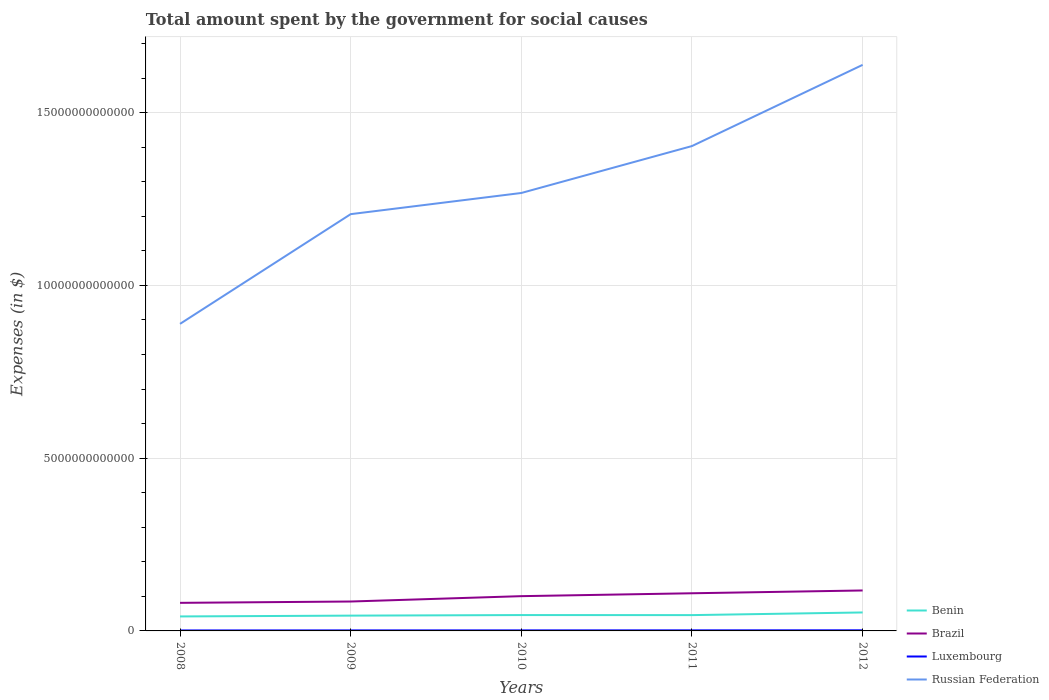Is the number of lines equal to the number of legend labels?
Give a very brief answer. Yes. Across all years, what is the maximum amount spent for social causes by the government in Benin?
Give a very brief answer. 4.19e+11. In which year was the amount spent for social causes by the government in Russian Federation maximum?
Offer a very short reply. 2008. What is the total amount spent for social causes by the government in Brazil in the graph?
Your answer should be compact. -1.55e+11. What is the difference between the highest and the second highest amount spent for social causes by the government in Brazil?
Your response must be concise. 3.58e+11. How many lines are there?
Make the answer very short. 4. What is the difference between two consecutive major ticks on the Y-axis?
Your answer should be very brief. 5.00e+12. Are the values on the major ticks of Y-axis written in scientific E-notation?
Your answer should be compact. No. What is the title of the graph?
Offer a very short reply. Total amount spent by the government for social causes. Does "Bahamas" appear as one of the legend labels in the graph?
Your answer should be very brief. No. What is the label or title of the Y-axis?
Provide a succinct answer. Expenses (in $). What is the Expenses (in $) of Benin in 2008?
Your response must be concise. 4.19e+11. What is the Expenses (in $) in Brazil in 2008?
Offer a very short reply. 8.13e+11. What is the Expenses (in $) of Luxembourg in 2008?
Keep it short and to the point. 1.34e+1. What is the Expenses (in $) in Russian Federation in 2008?
Provide a short and direct response. 8.89e+12. What is the Expenses (in $) of Benin in 2009?
Offer a very short reply. 4.43e+11. What is the Expenses (in $) in Brazil in 2009?
Your answer should be compact. 8.51e+11. What is the Expenses (in $) of Luxembourg in 2009?
Ensure brevity in your answer.  1.47e+1. What is the Expenses (in $) in Russian Federation in 2009?
Keep it short and to the point. 1.21e+13. What is the Expenses (in $) of Benin in 2010?
Offer a very short reply. 4.59e+11. What is the Expenses (in $) in Brazil in 2010?
Give a very brief answer. 1.01e+12. What is the Expenses (in $) in Luxembourg in 2010?
Your answer should be very brief. 1.56e+1. What is the Expenses (in $) of Russian Federation in 2010?
Offer a terse response. 1.27e+13. What is the Expenses (in $) in Benin in 2011?
Give a very brief answer. 4.58e+11. What is the Expenses (in $) in Brazil in 2011?
Provide a succinct answer. 1.09e+12. What is the Expenses (in $) of Luxembourg in 2011?
Your answer should be very brief. 1.63e+1. What is the Expenses (in $) of Russian Federation in 2011?
Keep it short and to the point. 1.40e+13. What is the Expenses (in $) in Benin in 2012?
Your response must be concise. 5.35e+11. What is the Expenses (in $) of Brazil in 2012?
Ensure brevity in your answer.  1.17e+12. What is the Expenses (in $) of Luxembourg in 2012?
Offer a very short reply. 1.76e+1. What is the Expenses (in $) of Russian Federation in 2012?
Offer a very short reply. 1.64e+13. Across all years, what is the maximum Expenses (in $) of Benin?
Make the answer very short. 5.35e+11. Across all years, what is the maximum Expenses (in $) of Brazil?
Your answer should be compact. 1.17e+12. Across all years, what is the maximum Expenses (in $) in Luxembourg?
Offer a very short reply. 1.76e+1. Across all years, what is the maximum Expenses (in $) of Russian Federation?
Keep it short and to the point. 1.64e+13. Across all years, what is the minimum Expenses (in $) in Benin?
Your answer should be compact. 4.19e+11. Across all years, what is the minimum Expenses (in $) in Brazil?
Offer a terse response. 8.13e+11. Across all years, what is the minimum Expenses (in $) in Luxembourg?
Your response must be concise. 1.34e+1. Across all years, what is the minimum Expenses (in $) of Russian Federation?
Your answer should be compact. 8.89e+12. What is the total Expenses (in $) of Benin in the graph?
Make the answer very short. 2.31e+12. What is the total Expenses (in $) of Brazil in the graph?
Provide a short and direct response. 4.93e+12. What is the total Expenses (in $) in Luxembourg in the graph?
Keep it short and to the point. 7.76e+1. What is the total Expenses (in $) in Russian Federation in the graph?
Keep it short and to the point. 6.40e+13. What is the difference between the Expenses (in $) in Benin in 2008 and that in 2009?
Keep it short and to the point. -2.35e+1. What is the difference between the Expenses (in $) in Brazil in 2008 and that in 2009?
Your answer should be very brief. -3.85e+1. What is the difference between the Expenses (in $) of Luxembourg in 2008 and that in 2009?
Your answer should be very brief. -1.27e+09. What is the difference between the Expenses (in $) of Russian Federation in 2008 and that in 2009?
Ensure brevity in your answer.  -3.18e+12. What is the difference between the Expenses (in $) in Benin in 2008 and that in 2010?
Offer a terse response. -3.99e+1. What is the difference between the Expenses (in $) in Brazil in 2008 and that in 2010?
Your answer should be compact. -1.93e+11. What is the difference between the Expenses (in $) of Luxembourg in 2008 and that in 2010?
Make the answer very short. -2.11e+09. What is the difference between the Expenses (in $) of Russian Federation in 2008 and that in 2010?
Your answer should be very brief. -3.79e+12. What is the difference between the Expenses (in $) of Benin in 2008 and that in 2011?
Your response must be concise. -3.85e+1. What is the difference between the Expenses (in $) of Brazil in 2008 and that in 2011?
Offer a very short reply. -2.77e+11. What is the difference between the Expenses (in $) of Luxembourg in 2008 and that in 2011?
Give a very brief answer. -2.88e+09. What is the difference between the Expenses (in $) in Russian Federation in 2008 and that in 2011?
Offer a very short reply. -5.15e+12. What is the difference between the Expenses (in $) in Benin in 2008 and that in 2012?
Your answer should be compact. -1.16e+11. What is the difference between the Expenses (in $) in Brazil in 2008 and that in 2012?
Make the answer very short. -3.58e+11. What is the difference between the Expenses (in $) in Luxembourg in 2008 and that in 2012?
Provide a succinct answer. -4.14e+09. What is the difference between the Expenses (in $) of Russian Federation in 2008 and that in 2012?
Provide a short and direct response. -7.50e+12. What is the difference between the Expenses (in $) of Benin in 2009 and that in 2010?
Ensure brevity in your answer.  -1.64e+1. What is the difference between the Expenses (in $) in Brazil in 2009 and that in 2010?
Offer a terse response. -1.55e+11. What is the difference between the Expenses (in $) in Luxembourg in 2009 and that in 2010?
Provide a short and direct response. -8.37e+08. What is the difference between the Expenses (in $) of Russian Federation in 2009 and that in 2010?
Provide a succinct answer. -6.13e+11. What is the difference between the Expenses (in $) of Benin in 2009 and that in 2011?
Offer a very short reply. -1.50e+1. What is the difference between the Expenses (in $) of Brazil in 2009 and that in 2011?
Make the answer very short. -2.39e+11. What is the difference between the Expenses (in $) of Luxembourg in 2009 and that in 2011?
Give a very brief answer. -1.61e+09. What is the difference between the Expenses (in $) in Russian Federation in 2009 and that in 2011?
Ensure brevity in your answer.  -1.97e+12. What is the difference between the Expenses (in $) of Benin in 2009 and that in 2012?
Ensure brevity in your answer.  -9.20e+1. What is the difference between the Expenses (in $) in Brazil in 2009 and that in 2012?
Your answer should be very brief. -3.20e+11. What is the difference between the Expenses (in $) of Luxembourg in 2009 and that in 2012?
Offer a terse response. -2.87e+09. What is the difference between the Expenses (in $) of Russian Federation in 2009 and that in 2012?
Your response must be concise. -4.32e+12. What is the difference between the Expenses (in $) in Benin in 2010 and that in 2011?
Provide a short and direct response. 1.35e+09. What is the difference between the Expenses (in $) of Brazil in 2010 and that in 2011?
Provide a succinct answer. -8.37e+1. What is the difference between the Expenses (in $) in Luxembourg in 2010 and that in 2011?
Offer a very short reply. -7.72e+08. What is the difference between the Expenses (in $) in Russian Federation in 2010 and that in 2011?
Give a very brief answer. -1.36e+12. What is the difference between the Expenses (in $) in Benin in 2010 and that in 2012?
Ensure brevity in your answer.  -7.57e+1. What is the difference between the Expenses (in $) in Brazil in 2010 and that in 2012?
Your response must be concise. -1.65e+11. What is the difference between the Expenses (in $) in Luxembourg in 2010 and that in 2012?
Offer a terse response. -2.03e+09. What is the difference between the Expenses (in $) in Russian Federation in 2010 and that in 2012?
Provide a short and direct response. -3.71e+12. What is the difference between the Expenses (in $) in Benin in 2011 and that in 2012?
Ensure brevity in your answer.  -7.70e+1. What is the difference between the Expenses (in $) of Brazil in 2011 and that in 2012?
Make the answer very short. -8.09e+1. What is the difference between the Expenses (in $) in Luxembourg in 2011 and that in 2012?
Provide a succinct answer. -1.26e+09. What is the difference between the Expenses (in $) in Russian Federation in 2011 and that in 2012?
Your response must be concise. -2.35e+12. What is the difference between the Expenses (in $) in Benin in 2008 and the Expenses (in $) in Brazil in 2009?
Your answer should be compact. -4.32e+11. What is the difference between the Expenses (in $) in Benin in 2008 and the Expenses (in $) in Luxembourg in 2009?
Ensure brevity in your answer.  4.04e+11. What is the difference between the Expenses (in $) of Benin in 2008 and the Expenses (in $) of Russian Federation in 2009?
Keep it short and to the point. -1.16e+13. What is the difference between the Expenses (in $) of Brazil in 2008 and the Expenses (in $) of Luxembourg in 2009?
Offer a very short reply. 7.98e+11. What is the difference between the Expenses (in $) in Brazil in 2008 and the Expenses (in $) in Russian Federation in 2009?
Offer a terse response. -1.13e+13. What is the difference between the Expenses (in $) in Luxembourg in 2008 and the Expenses (in $) in Russian Federation in 2009?
Offer a terse response. -1.20e+13. What is the difference between the Expenses (in $) of Benin in 2008 and the Expenses (in $) of Brazil in 2010?
Provide a succinct answer. -5.87e+11. What is the difference between the Expenses (in $) in Benin in 2008 and the Expenses (in $) in Luxembourg in 2010?
Offer a very short reply. 4.04e+11. What is the difference between the Expenses (in $) in Benin in 2008 and the Expenses (in $) in Russian Federation in 2010?
Your answer should be very brief. -1.23e+13. What is the difference between the Expenses (in $) of Brazil in 2008 and the Expenses (in $) of Luxembourg in 2010?
Provide a succinct answer. 7.97e+11. What is the difference between the Expenses (in $) in Brazil in 2008 and the Expenses (in $) in Russian Federation in 2010?
Make the answer very short. -1.19e+13. What is the difference between the Expenses (in $) of Luxembourg in 2008 and the Expenses (in $) of Russian Federation in 2010?
Keep it short and to the point. -1.27e+13. What is the difference between the Expenses (in $) in Benin in 2008 and the Expenses (in $) in Brazil in 2011?
Provide a short and direct response. -6.71e+11. What is the difference between the Expenses (in $) of Benin in 2008 and the Expenses (in $) of Luxembourg in 2011?
Provide a short and direct response. 4.03e+11. What is the difference between the Expenses (in $) of Benin in 2008 and the Expenses (in $) of Russian Federation in 2011?
Make the answer very short. -1.36e+13. What is the difference between the Expenses (in $) of Brazil in 2008 and the Expenses (in $) of Luxembourg in 2011?
Ensure brevity in your answer.  7.96e+11. What is the difference between the Expenses (in $) in Brazil in 2008 and the Expenses (in $) in Russian Federation in 2011?
Your answer should be compact. -1.32e+13. What is the difference between the Expenses (in $) in Luxembourg in 2008 and the Expenses (in $) in Russian Federation in 2011?
Offer a terse response. -1.40e+13. What is the difference between the Expenses (in $) in Benin in 2008 and the Expenses (in $) in Brazil in 2012?
Offer a very short reply. -7.52e+11. What is the difference between the Expenses (in $) of Benin in 2008 and the Expenses (in $) of Luxembourg in 2012?
Offer a terse response. 4.02e+11. What is the difference between the Expenses (in $) of Benin in 2008 and the Expenses (in $) of Russian Federation in 2012?
Make the answer very short. -1.60e+13. What is the difference between the Expenses (in $) in Brazil in 2008 and the Expenses (in $) in Luxembourg in 2012?
Make the answer very short. 7.95e+11. What is the difference between the Expenses (in $) of Brazil in 2008 and the Expenses (in $) of Russian Federation in 2012?
Your response must be concise. -1.56e+13. What is the difference between the Expenses (in $) of Luxembourg in 2008 and the Expenses (in $) of Russian Federation in 2012?
Provide a succinct answer. -1.64e+13. What is the difference between the Expenses (in $) of Benin in 2009 and the Expenses (in $) of Brazil in 2010?
Keep it short and to the point. -5.64e+11. What is the difference between the Expenses (in $) of Benin in 2009 and the Expenses (in $) of Luxembourg in 2010?
Give a very brief answer. 4.27e+11. What is the difference between the Expenses (in $) in Benin in 2009 and the Expenses (in $) in Russian Federation in 2010?
Give a very brief answer. -1.22e+13. What is the difference between the Expenses (in $) of Brazil in 2009 and the Expenses (in $) of Luxembourg in 2010?
Your response must be concise. 8.36e+11. What is the difference between the Expenses (in $) in Brazil in 2009 and the Expenses (in $) in Russian Federation in 2010?
Offer a terse response. -1.18e+13. What is the difference between the Expenses (in $) of Luxembourg in 2009 and the Expenses (in $) of Russian Federation in 2010?
Make the answer very short. -1.27e+13. What is the difference between the Expenses (in $) in Benin in 2009 and the Expenses (in $) in Brazil in 2011?
Offer a terse response. -6.47e+11. What is the difference between the Expenses (in $) of Benin in 2009 and the Expenses (in $) of Luxembourg in 2011?
Your answer should be compact. 4.26e+11. What is the difference between the Expenses (in $) in Benin in 2009 and the Expenses (in $) in Russian Federation in 2011?
Your answer should be very brief. -1.36e+13. What is the difference between the Expenses (in $) in Brazil in 2009 and the Expenses (in $) in Luxembourg in 2011?
Your answer should be very brief. 8.35e+11. What is the difference between the Expenses (in $) of Brazil in 2009 and the Expenses (in $) of Russian Federation in 2011?
Offer a terse response. -1.32e+13. What is the difference between the Expenses (in $) in Luxembourg in 2009 and the Expenses (in $) in Russian Federation in 2011?
Offer a very short reply. -1.40e+13. What is the difference between the Expenses (in $) of Benin in 2009 and the Expenses (in $) of Brazil in 2012?
Offer a very short reply. -7.28e+11. What is the difference between the Expenses (in $) of Benin in 2009 and the Expenses (in $) of Luxembourg in 2012?
Give a very brief answer. 4.25e+11. What is the difference between the Expenses (in $) of Benin in 2009 and the Expenses (in $) of Russian Federation in 2012?
Provide a short and direct response. -1.59e+13. What is the difference between the Expenses (in $) in Brazil in 2009 and the Expenses (in $) in Luxembourg in 2012?
Your answer should be compact. 8.34e+11. What is the difference between the Expenses (in $) in Brazil in 2009 and the Expenses (in $) in Russian Federation in 2012?
Your response must be concise. -1.55e+13. What is the difference between the Expenses (in $) in Luxembourg in 2009 and the Expenses (in $) in Russian Federation in 2012?
Provide a short and direct response. -1.64e+13. What is the difference between the Expenses (in $) in Benin in 2010 and the Expenses (in $) in Brazil in 2011?
Offer a terse response. -6.31e+11. What is the difference between the Expenses (in $) of Benin in 2010 and the Expenses (in $) of Luxembourg in 2011?
Your response must be concise. 4.43e+11. What is the difference between the Expenses (in $) of Benin in 2010 and the Expenses (in $) of Russian Federation in 2011?
Ensure brevity in your answer.  -1.36e+13. What is the difference between the Expenses (in $) in Brazil in 2010 and the Expenses (in $) in Luxembourg in 2011?
Offer a terse response. 9.90e+11. What is the difference between the Expenses (in $) in Brazil in 2010 and the Expenses (in $) in Russian Federation in 2011?
Your answer should be very brief. -1.30e+13. What is the difference between the Expenses (in $) of Luxembourg in 2010 and the Expenses (in $) of Russian Federation in 2011?
Your answer should be compact. -1.40e+13. What is the difference between the Expenses (in $) in Benin in 2010 and the Expenses (in $) in Brazil in 2012?
Keep it short and to the point. -7.12e+11. What is the difference between the Expenses (in $) of Benin in 2010 and the Expenses (in $) of Luxembourg in 2012?
Offer a very short reply. 4.41e+11. What is the difference between the Expenses (in $) of Benin in 2010 and the Expenses (in $) of Russian Federation in 2012?
Your answer should be very brief. -1.59e+13. What is the difference between the Expenses (in $) in Brazil in 2010 and the Expenses (in $) in Luxembourg in 2012?
Provide a short and direct response. 9.89e+11. What is the difference between the Expenses (in $) in Brazil in 2010 and the Expenses (in $) in Russian Federation in 2012?
Offer a terse response. -1.54e+13. What is the difference between the Expenses (in $) in Luxembourg in 2010 and the Expenses (in $) in Russian Federation in 2012?
Ensure brevity in your answer.  -1.64e+13. What is the difference between the Expenses (in $) in Benin in 2011 and the Expenses (in $) in Brazil in 2012?
Make the answer very short. -7.13e+11. What is the difference between the Expenses (in $) of Benin in 2011 and the Expenses (in $) of Luxembourg in 2012?
Keep it short and to the point. 4.40e+11. What is the difference between the Expenses (in $) of Benin in 2011 and the Expenses (in $) of Russian Federation in 2012?
Your answer should be compact. -1.59e+13. What is the difference between the Expenses (in $) in Brazil in 2011 and the Expenses (in $) in Luxembourg in 2012?
Offer a terse response. 1.07e+12. What is the difference between the Expenses (in $) of Brazil in 2011 and the Expenses (in $) of Russian Federation in 2012?
Keep it short and to the point. -1.53e+13. What is the difference between the Expenses (in $) of Luxembourg in 2011 and the Expenses (in $) of Russian Federation in 2012?
Ensure brevity in your answer.  -1.64e+13. What is the average Expenses (in $) of Benin per year?
Ensure brevity in your answer.  4.63e+11. What is the average Expenses (in $) in Brazil per year?
Provide a short and direct response. 9.86e+11. What is the average Expenses (in $) in Luxembourg per year?
Provide a succinct answer. 1.55e+1. What is the average Expenses (in $) in Russian Federation per year?
Ensure brevity in your answer.  1.28e+13. In the year 2008, what is the difference between the Expenses (in $) of Benin and Expenses (in $) of Brazil?
Provide a short and direct response. -3.94e+11. In the year 2008, what is the difference between the Expenses (in $) in Benin and Expenses (in $) in Luxembourg?
Give a very brief answer. 4.06e+11. In the year 2008, what is the difference between the Expenses (in $) in Benin and Expenses (in $) in Russian Federation?
Your response must be concise. -8.47e+12. In the year 2008, what is the difference between the Expenses (in $) in Brazil and Expenses (in $) in Luxembourg?
Your answer should be compact. 7.99e+11. In the year 2008, what is the difference between the Expenses (in $) in Brazil and Expenses (in $) in Russian Federation?
Your response must be concise. -8.08e+12. In the year 2008, what is the difference between the Expenses (in $) in Luxembourg and Expenses (in $) in Russian Federation?
Ensure brevity in your answer.  -8.87e+12. In the year 2009, what is the difference between the Expenses (in $) in Benin and Expenses (in $) in Brazil?
Keep it short and to the point. -4.09e+11. In the year 2009, what is the difference between the Expenses (in $) in Benin and Expenses (in $) in Luxembourg?
Your answer should be compact. 4.28e+11. In the year 2009, what is the difference between the Expenses (in $) of Benin and Expenses (in $) of Russian Federation?
Your answer should be very brief. -1.16e+13. In the year 2009, what is the difference between the Expenses (in $) in Brazil and Expenses (in $) in Luxembourg?
Keep it short and to the point. 8.37e+11. In the year 2009, what is the difference between the Expenses (in $) in Brazil and Expenses (in $) in Russian Federation?
Offer a very short reply. -1.12e+13. In the year 2009, what is the difference between the Expenses (in $) of Luxembourg and Expenses (in $) of Russian Federation?
Your answer should be compact. -1.20e+13. In the year 2010, what is the difference between the Expenses (in $) of Benin and Expenses (in $) of Brazil?
Provide a succinct answer. -5.47e+11. In the year 2010, what is the difference between the Expenses (in $) in Benin and Expenses (in $) in Luxembourg?
Your response must be concise. 4.43e+11. In the year 2010, what is the difference between the Expenses (in $) of Benin and Expenses (in $) of Russian Federation?
Your answer should be compact. -1.22e+13. In the year 2010, what is the difference between the Expenses (in $) in Brazil and Expenses (in $) in Luxembourg?
Provide a succinct answer. 9.91e+11. In the year 2010, what is the difference between the Expenses (in $) of Brazil and Expenses (in $) of Russian Federation?
Your response must be concise. -1.17e+13. In the year 2010, what is the difference between the Expenses (in $) of Luxembourg and Expenses (in $) of Russian Federation?
Your response must be concise. -1.27e+13. In the year 2011, what is the difference between the Expenses (in $) of Benin and Expenses (in $) of Brazil?
Provide a succinct answer. -6.32e+11. In the year 2011, what is the difference between the Expenses (in $) of Benin and Expenses (in $) of Luxembourg?
Provide a short and direct response. 4.41e+11. In the year 2011, what is the difference between the Expenses (in $) of Benin and Expenses (in $) of Russian Federation?
Your answer should be compact. -1.36e+13. In the year 2011, what is the difference between the Expenses (in $) in Brazil and Expenses (in $) in Luxembourg?
Make the answer very short. 1.07e+12. In the year 2011, what is the difference between the Expenses (in $) in Brazil and Expenses (in $) in Russian Federation?
Make the answer very short. -1.29e+13. In the year 2011, what is the difference between the Expenses (in $) of Luxembourg and Expenses (in $) of Russian Federation?
Keep it short and to the point. -1.40e+13. In the year 2012, what is the difference between the Expenses (in $) in Benin and Expenses (in $) in Brazil?
Keep it short and to the point. -6.36e+11. In the year 2012, what is the difference between the Expenses (in $) of Benin and Expenses (in $) of Luxembourg?
Keep it short and to the point. 5.17e+11. In the year 2012, what is the difference between the Expenses (in $) in Benin and Expenses (in $) in Russian Federation?
Offer a very short reply. -1.58e+13. In the year 2012, what is the difference between the Expenses (in $) of Brazil and Expenses (in $) of Luxembourg?
Provide a short and direct response. 1.15e+12. In the year 2012, what is the difference between the Expenses (in $) of Brazil and Expenses (in $) of Russian Federation?
Offer a very short reply. -1.52e+13. In the year 2012, what is the difference between the Expenses (in $) in Luxembourg and Expenses (in $) in Russian Federation?
Offer a terse response. -1.64e+13. What is the ratio of the Expenses (in $) in Benin in 2008 to that in 2009?
Your answer should be compact. 0.95. What is the ratio of the Expenses (in $) of Brazil in 2008 to that in 2009?
Keep it short and to the point. 0.95. What is the ratio of the Expenses (in $) of Luxembourg in 2008 to that in 2009?
Ensure brevity in your answer.  0.91. What is the ratio of the Expenses (in $) of Russian Federation in 2008 to that in 2009?
Give a very brief answer. 0.74. What is the ratio of the Expenses (in $) of Benin in 2008 to that in 2010?
Offer a very short reply. 0.91. What is the ratio of the Expenses (in $) in Brazil in 2008 to that in 2010?
Make the answer very short. 0.81. What is the ratio of the Expenses (in $) in Luxembourg in 2008 to that in 2010?
Keep it short and to the point. 0.86. What is the ratio of the Expenses (in $) of Russian Federation in 2008 to that in 2010?
Your answer should be very brief. 0.7. What is the ratio of the Expenses (in $) in Benin in 2008 to that in 2011?
Make the answer very short. 0.92. What is the ratio of the Expenses (in $) of Brazil in 2008 to that in 2011?
Your answer should be compact. 0.75. What is the ratio of the Expenses (in $) of Luxembourg in 2008 to that in 2011?
Keep it short and to the point. 0.82. What is the ratio of the Expenses (in $) in Russian Federation in 2008 to that in 2011?
Give a very brief answer. 0.63. What is the ratio of the Expenses (in $) in Benin in 2008 to that in 2012?
Provide a succinct answer. 0.78. What is the ratio of the Expenses (in $) of Brazil in 2008 to that in 2012?
Ensure brevity in your answer.  0.69. What is the ratio of the Expenses (in $) of Luxembourg in 2008 to that in 2012?
Offer a terse response. 0.76. What is the ratio of the Expenses (in $) of Russian Federation in 2008 to that in 2012?
Your answer should be very brief. 0.54. What is the ratio of the Expenses (in $) of Benin in 2009 to that in 2010?
Give a very brief answer. 0.96. What is the ratio of the Expenses (in $) in Brazil in 2009 to that in 2010?
Provide a short and direct response. 0.85. What is the ratio of the Expenses (in $) in Luxembourg in 2009 to that in 2010?
Offer a very short reply. 0.95. What is the ratio of the Expenses (in $) of Russian Federation in 2009 to that in 2010?
Keep it short and to the point. 0.95. What is the ratio of the Expenses (in $) of Benin in 2009 to that in 2011?
Provide a succinct answer. 0.97. What is the ratio of the Expenses (in $) in Brazil in 2009 to that in 2011?
Your answer should be very brief. 0.78. What is the ratio of the Expenses (in $) in Luxembourg in 2009 to that in 2011?
Provide a succinct answer. 0.9. What is the ratio of the Expenses (in $) of Russian Federation in 2009 to that in 2011?
Make the answer very short. 0.86. What is the ratio of the Expenses (in $) of Benin in 2009 to that in 2012?
Your answer should be compact. 0.83. What is the ratio of the Expenses (in $) in Brazil in 2009 to that in 2012?
Your answer should be compact. 0.73. What is the ratio of the Expenses (in $) of Luxembourg in 2009 to that in 2012?
Make the answer very short. 0.84. What is the ratio of the Expenses (in $) in Russian Federation in 2009 to that in 2012?
Your answer should be very brief. 0.74. What is the ratio of the Expenses (in $) of Brazil in 2010 to that in 2011?
Ensure brevity in your answer.  0.92. What is the ratio of the Expenses (in $) in Luxembourg in 2010 to that in 2011?
Your answer should be very brief. 0.95. What is the ratio of the Expenses (in $) in Russian Federation in 2010 to that in 2011?
Your answer should be very brief. 0.9. What is the ratio of the Expenses (in $) of Benin in 2010 to that in 2012?
Offer a very short reply. 0.86. What is the ratio of the Expenses (in $) of Brazil in 2010 to that in 2012?
Offer a very short reply. 0.86. What is the ratio of the Expenses (in $) in Luxembourg in 2010 to that in 2012?
Give a very brief answer. 0.88. What is the ratio of the Expenses (in $) of Russian Federation in 2010 to that in 2012?
Make the answer very short. 0.77. What is the ratio of the Expenses (in $) in Benin in 2011 to that in 2012?
Ensure brevity in your answer.  0.86. What is the ratio of the Expenses (in $) in Brazil in 2011 to that in 2012?
Make the answer very short. 0.93. What is the ratio of the Expenses (in $) of Luxembourg in 2011 to that in 2012?
Offer a terse response. 0.93. What is the ratio of the Expenses (in $) in Russian Federation in 2011 to that in 2012?
Provide a succinct answer. 0.86. What is the difference between the highest and the second highest Expenses (in $) in Benin?
Give a very brief answer. 7.57e+1. What is the difference between the highest and the second highest Expenses (in $) in Brazil?
Give a very brief answer. 8.09e+1. What is the difference between the highest and the second highest Expenses (in $) in Luxembourg?
Give a very brief answer. 1.26e+09. What is the difference between the highest and the second highest Expenses (in $) in Russian Federation?
Your answer should be very brief. 2.35e+12. What is the difference between the highest and the lowest Expenses (in $) in Benin?
Offer a terse response. 1.16e+11. What is the difference between the highest and the lowest Expenses (in $) in Brazil?
Offer a terse response. 3.58e+11. What is the difference between the highest and the lowest Expenses (in $) of Luxembourg?
Your answer should be compact. 4.14e+09. What is the difference between the highest and the lowest Expenses (in $) of Russian Federation?
Keep it short and to the point. 7.50e+12. 